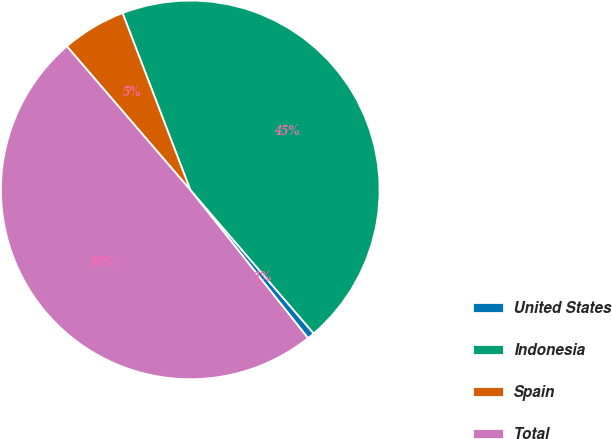Convert chart to OTSL. <chart><loc_0><loc_0><loc_500><loc_500><pie_chart><fcel>United States<fcel>Indonesia<fcel>Spain<fcel>Total<nl><fcel>0.62%<fcel>44.52%<fcel>5.48%<fcel>49.38%<nl></chart> 